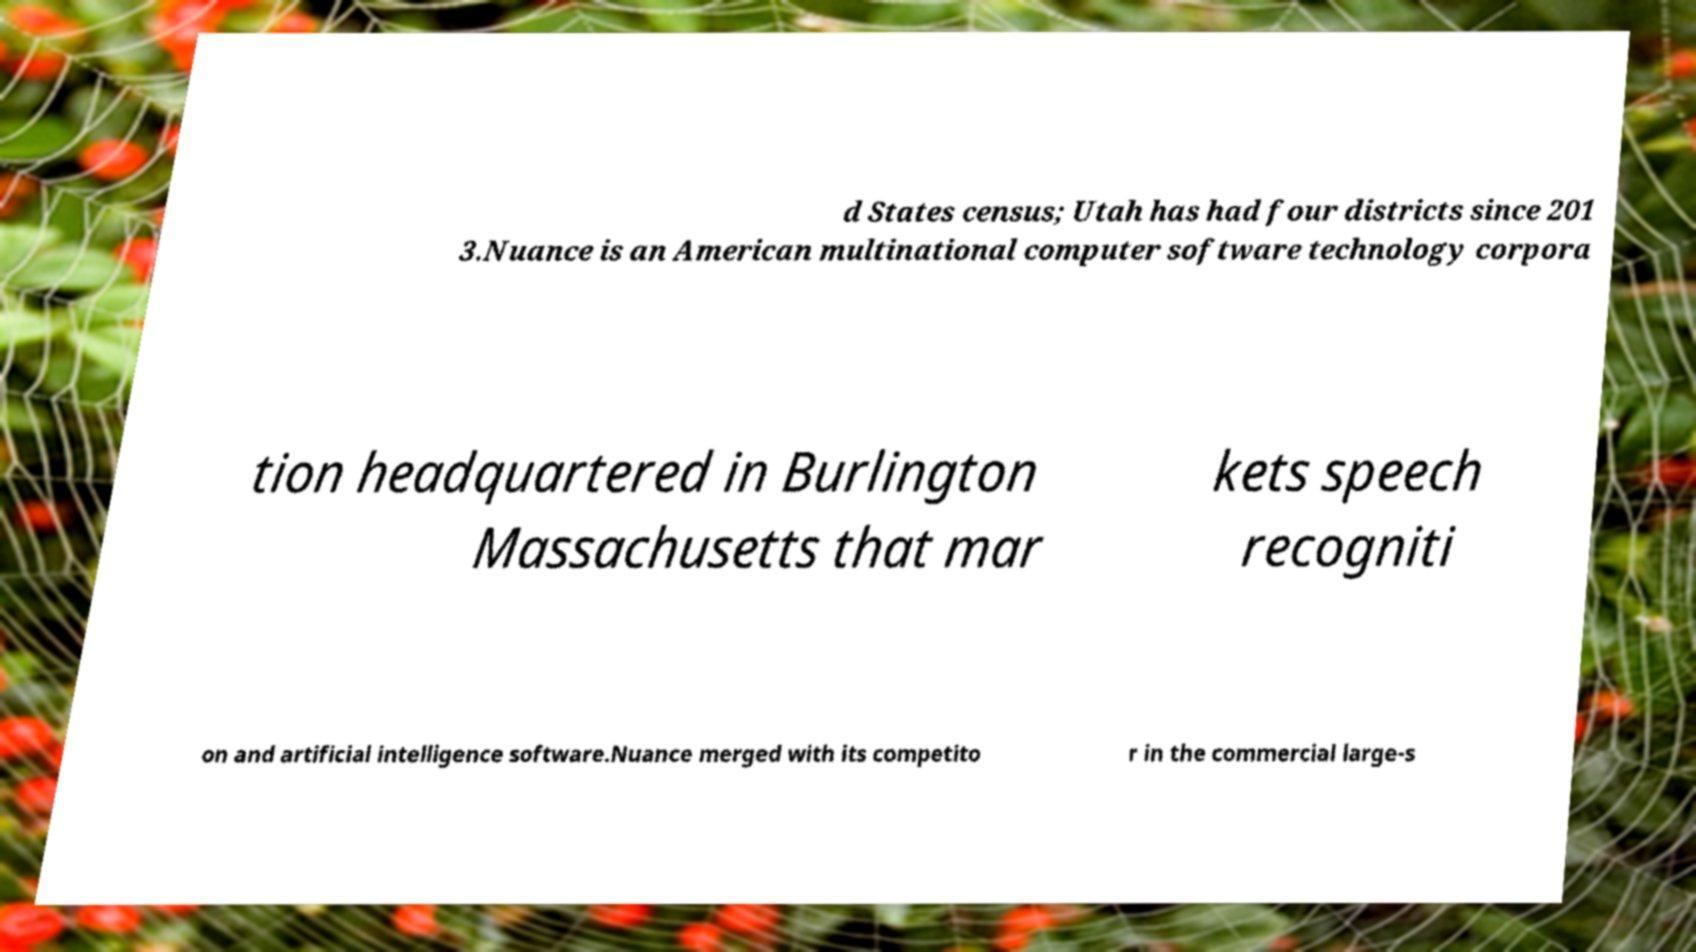Can you read and provide the text displayed in the image?This photo seems to have some interesting text. Can you extract and type it out for me? d States census; Utah has had four districts since 201 3.Nuance is an American multinational computer software technology corpora tion headquartered in Burlington Massachusetts that mar kets speech recogniti on and artificial intelligence software.Nuance merged with its competito r in the commercial large-s 